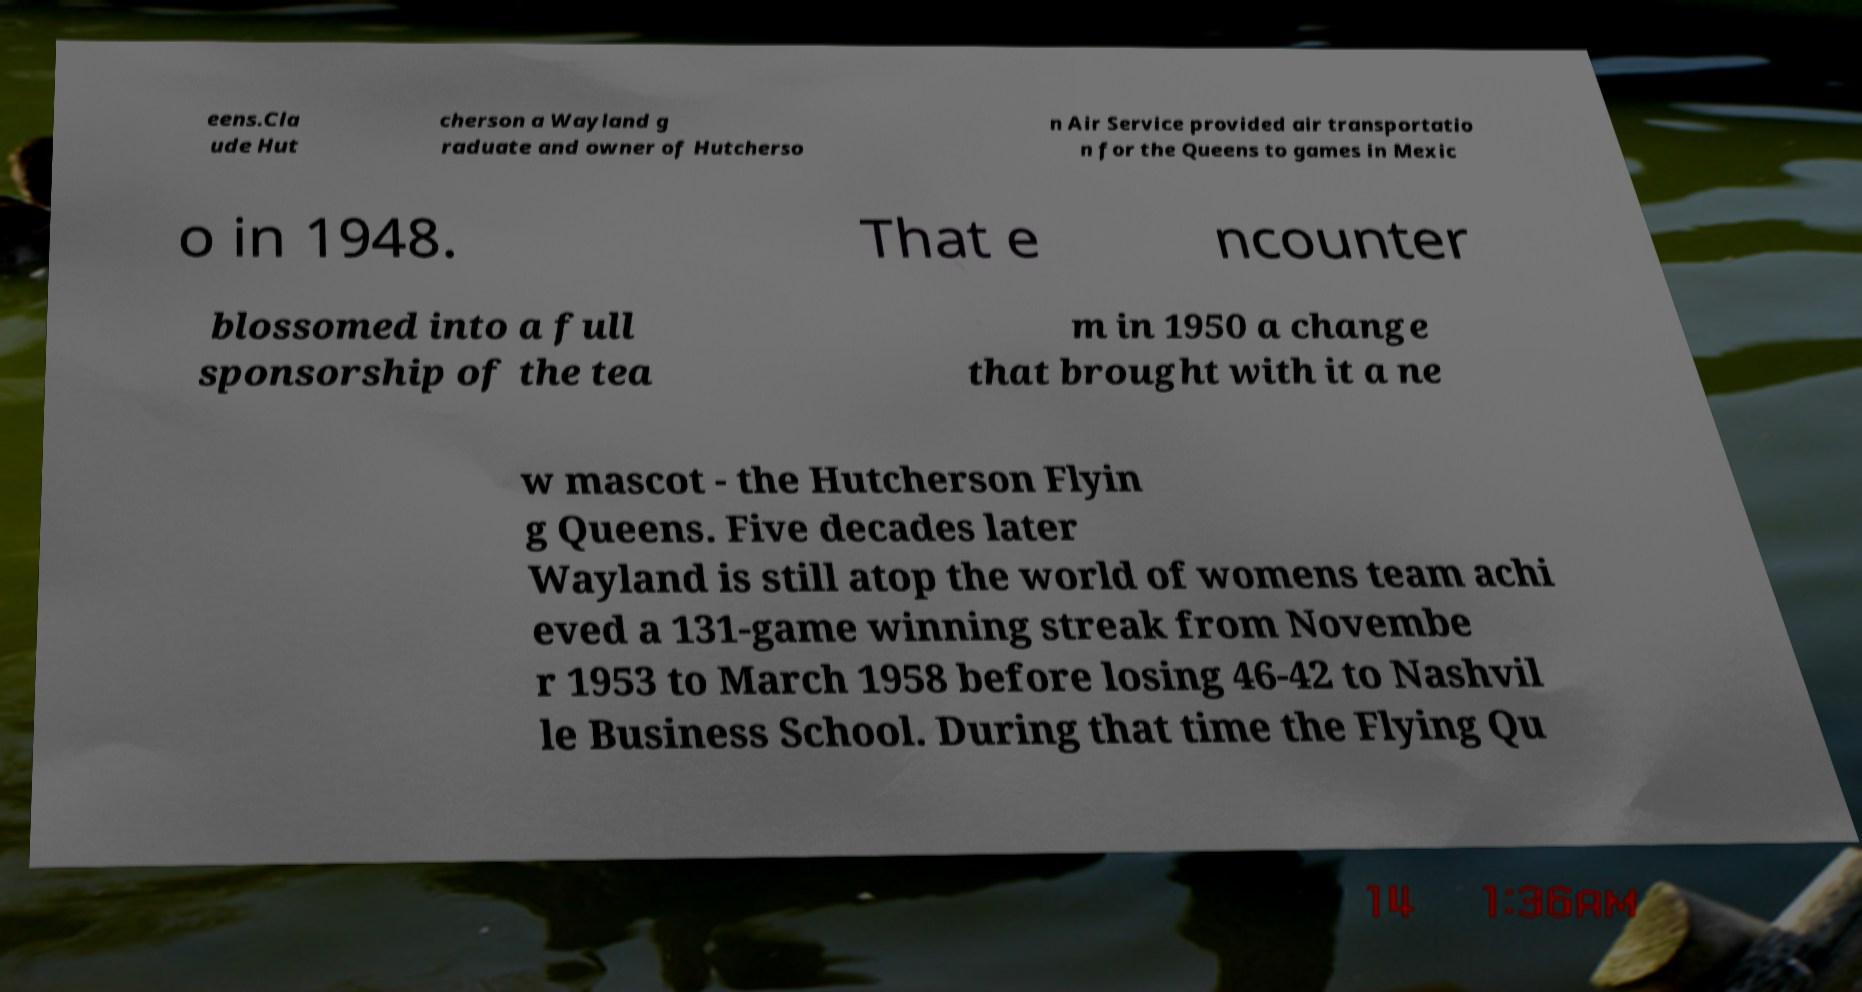Could you assist in decoding the text presented in this image and type it out clearly? eens.Cla ude Hut cherson a Wayland g raduate and owner of Hutcherso n Air Service provided air transportatio n for the Queens to games in Mexic o in 1948. That e ncounter blossomed into a full sponsorship of the tea m in 1950 a change that brought with it a ne w mascot - the Hutcherson Flyin g Queens. Five decades later Wayland is still atop the world of womens team achi eved a 131-game winning streak from Novembe r 1953 to March 1958 before losing 46-42 to Nashvil le Business School. During that time the Flying Qu 